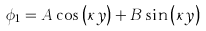Convert formula to latex. <formula><loc_0><loc_0><loc_500><loc_500>\phi _ { 1 } = A \cos \left ( \kappa y \right ) + B \sin \left ( \kappa y \right )</formula> 